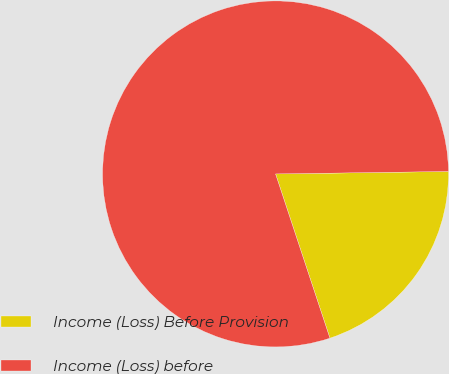Convert chart to OTSL. <chart><loc_0><loc_0><loc_500><loc_500><pie_chart><fcel>Income (Loss) Before Provision<fcel>Income (Loss) before<nl><fcel>20.14%<fcel>79.86%<nl></chart> 